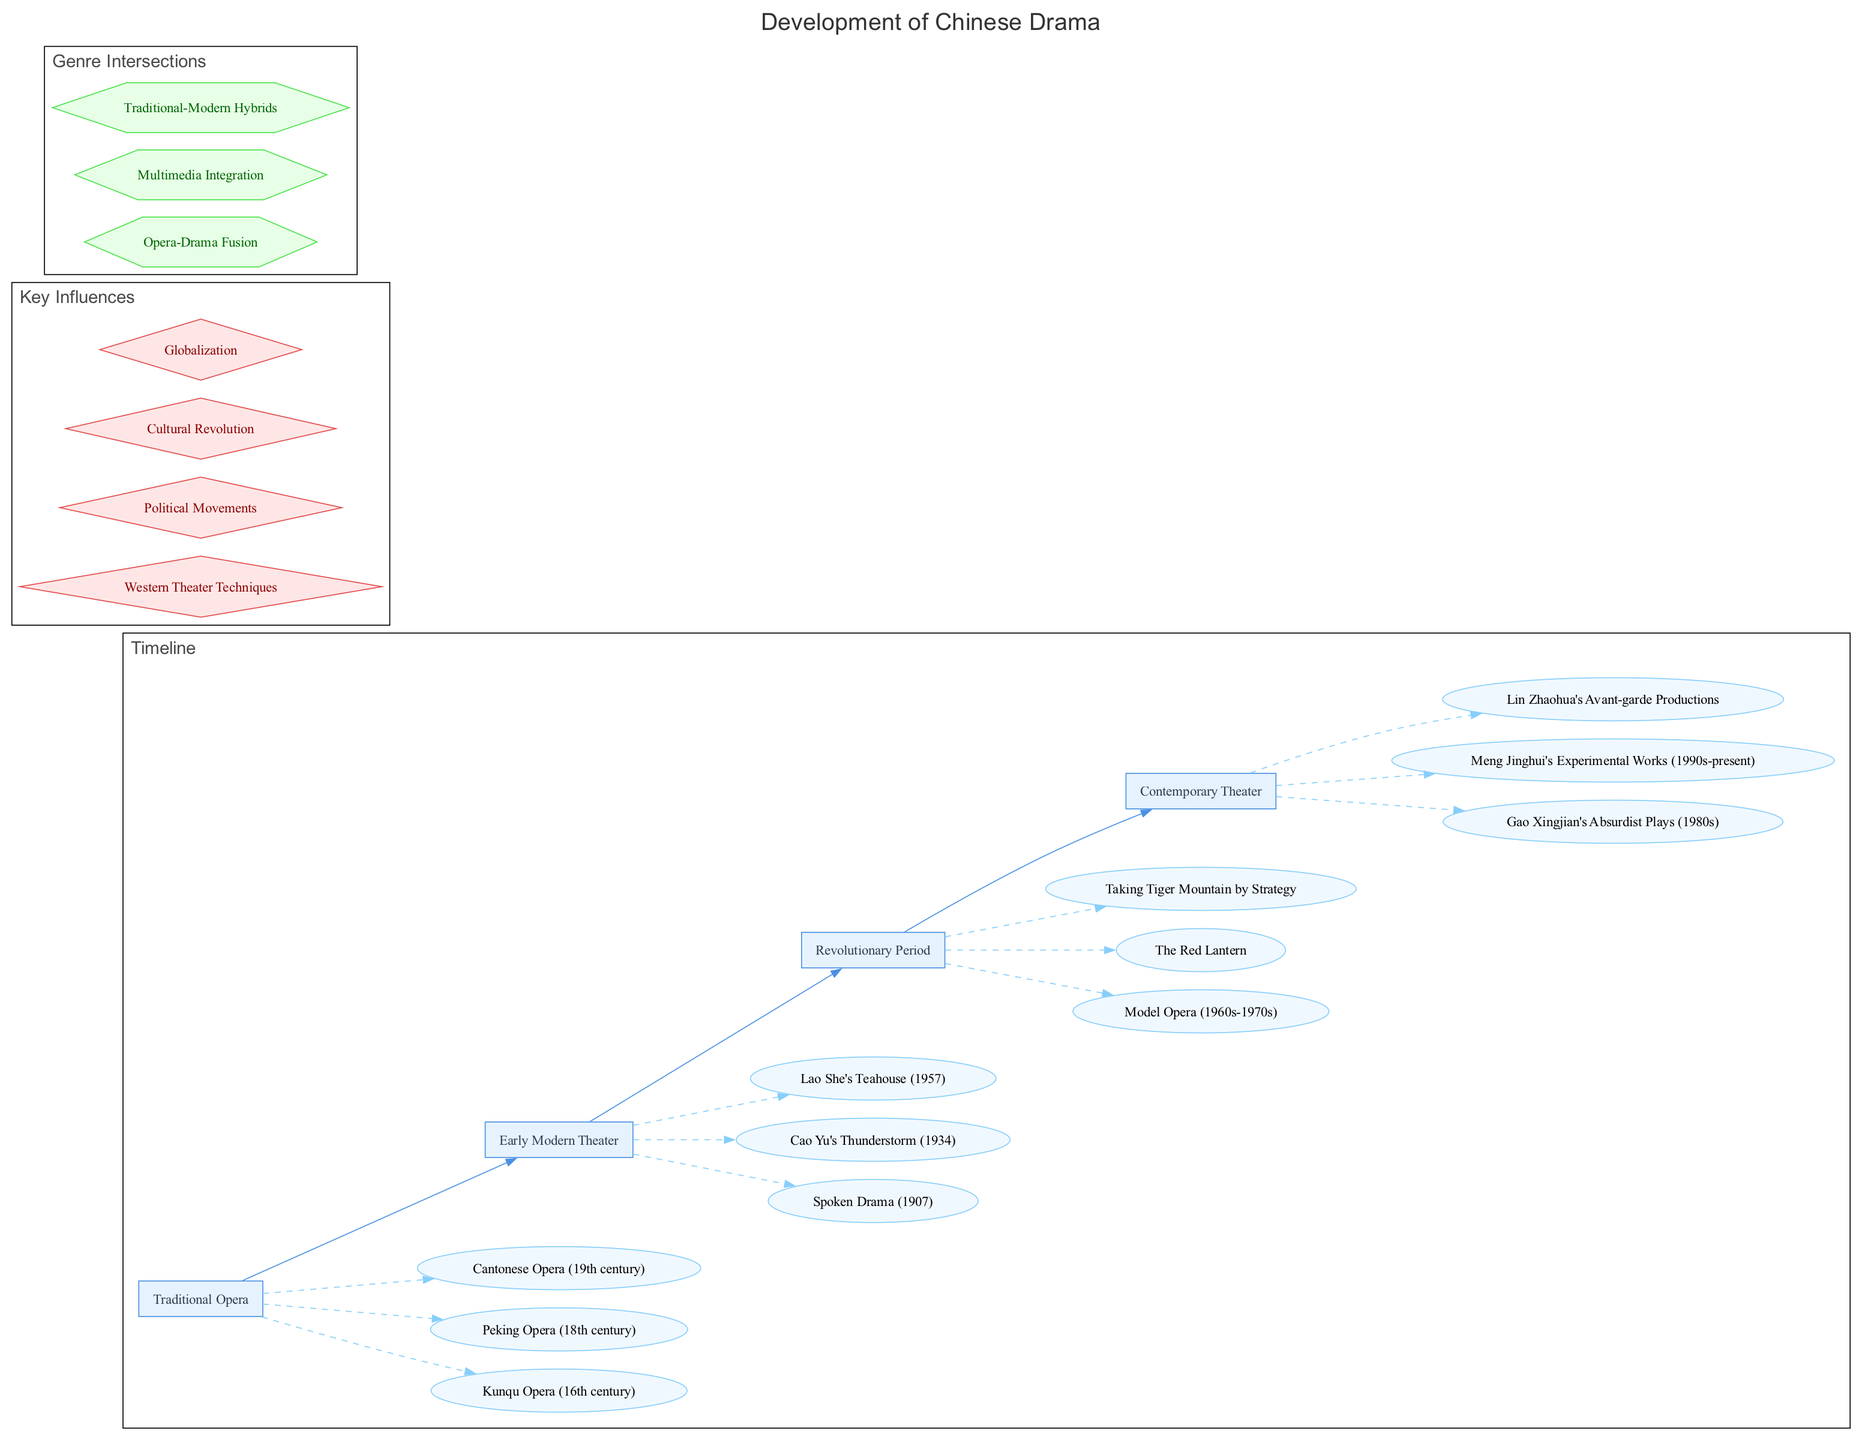What are the three types of drama in the Traditional Opera era? The diagram lists three elements under the "Traditional Opera" era: Kunqu Opera, Peking Opera, and Cantonese Opera. These are the major forms of traditional drama that developed during that time.
Answer: Kunqu Opera, Peking Opera, Cantonese Opera Which era features Gao Xingjian's plays? The diagram has a node for "Gao Xingjian's Absurdist Plays" under the "Contemporary Theater" era. This indicates that this particular type of drama emerged during this period of development in Chinese drama.
Answer: Contemporary Theater What is the relationship between the "Revolutionary Period" and Model Opera? According to the diagram, the "Revolutionary Period" era has "Model Opera" as one of its elements, indicating that Model Opera is a significant form of drama from this period in Chinese history.
Answer: Model Opera How many eras are represented in the timeline? The diagram displays four distinct eras in the timeline: Traditional Opera, Early Modern Theater, Revolutionary Period, and Contemporary Theater. This count provides an overview of the stages in the development of Chinese drama.
Answer: Four Name one key influence on the development of Chinese drama. The diagram identifies several key influences, including Western Theater Techniques, Political Movements, Cultural Revolution, and Globalization. Any one of these influences can be accurately stated as a key factor in shaping Chinese drama.
Answer: Western Theater Techniques What genre intersection involves multimedia? From the genre intersections presented in the diagram, "Multimedia Integration" explicitly indicates the intersection of different media types within drama, combining traditional forms with new technologies.
Answer: Multimedia Integration Which element under the "Early Modern Theater" era was written by Cao Yu? The diagram lists "Cao Yu's Thunderstorm" under the "Early Modern Theater" era, indicating that this play is an important work from that time.
Answer: Cao Yu's Thunderstorm Which era comes directly before the "Contemporary Theater"? The timeline shows "Revolutionary Period" as the era immediately preceding the "Contemporary Theater," linking the evolution of drama through these historical periods.
Answer: Revolutionary Period 